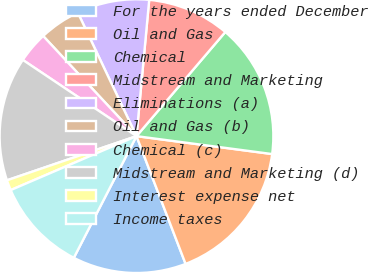Convert chart. <chart><loc_0><loc_0><loc_500><loc_500><pie_chart><fcel>For the years ended December<fcel>Oil and Gas<fcel>Chemical<fcel>Midstream and Marketing<fcel>Eliminations (a)<fcel>Oil and Gas (b)<fcel>Chemical (c)<fcel>Midstream and Marketing (d)<fcel>Interest expense net<fcel>Income taxes<nl><fcel>13.41%<fcel>17.07%<fcel>15.85%<fcel>9.76%<fcel>8.54%<fcel>4.88%<fcel>3.66%<fcel>14.63%<fcel>1.22%<fcel>10.98%<nl></chart> 